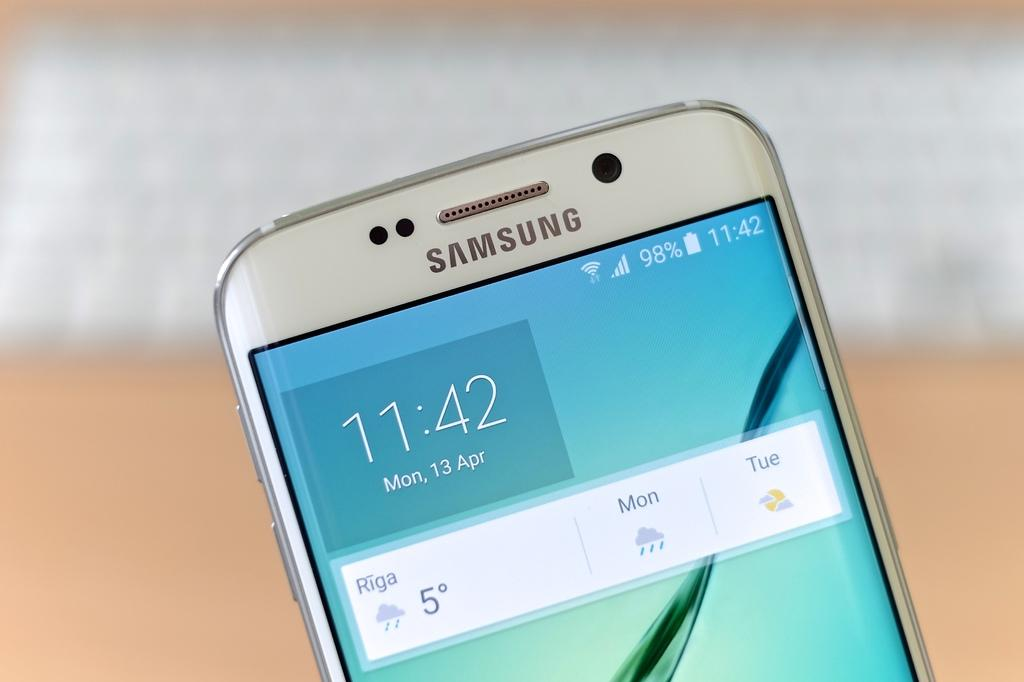<image>
Create a compact narrative representing the image presented. A Samsung cell phone displaying the time as 11:42. 